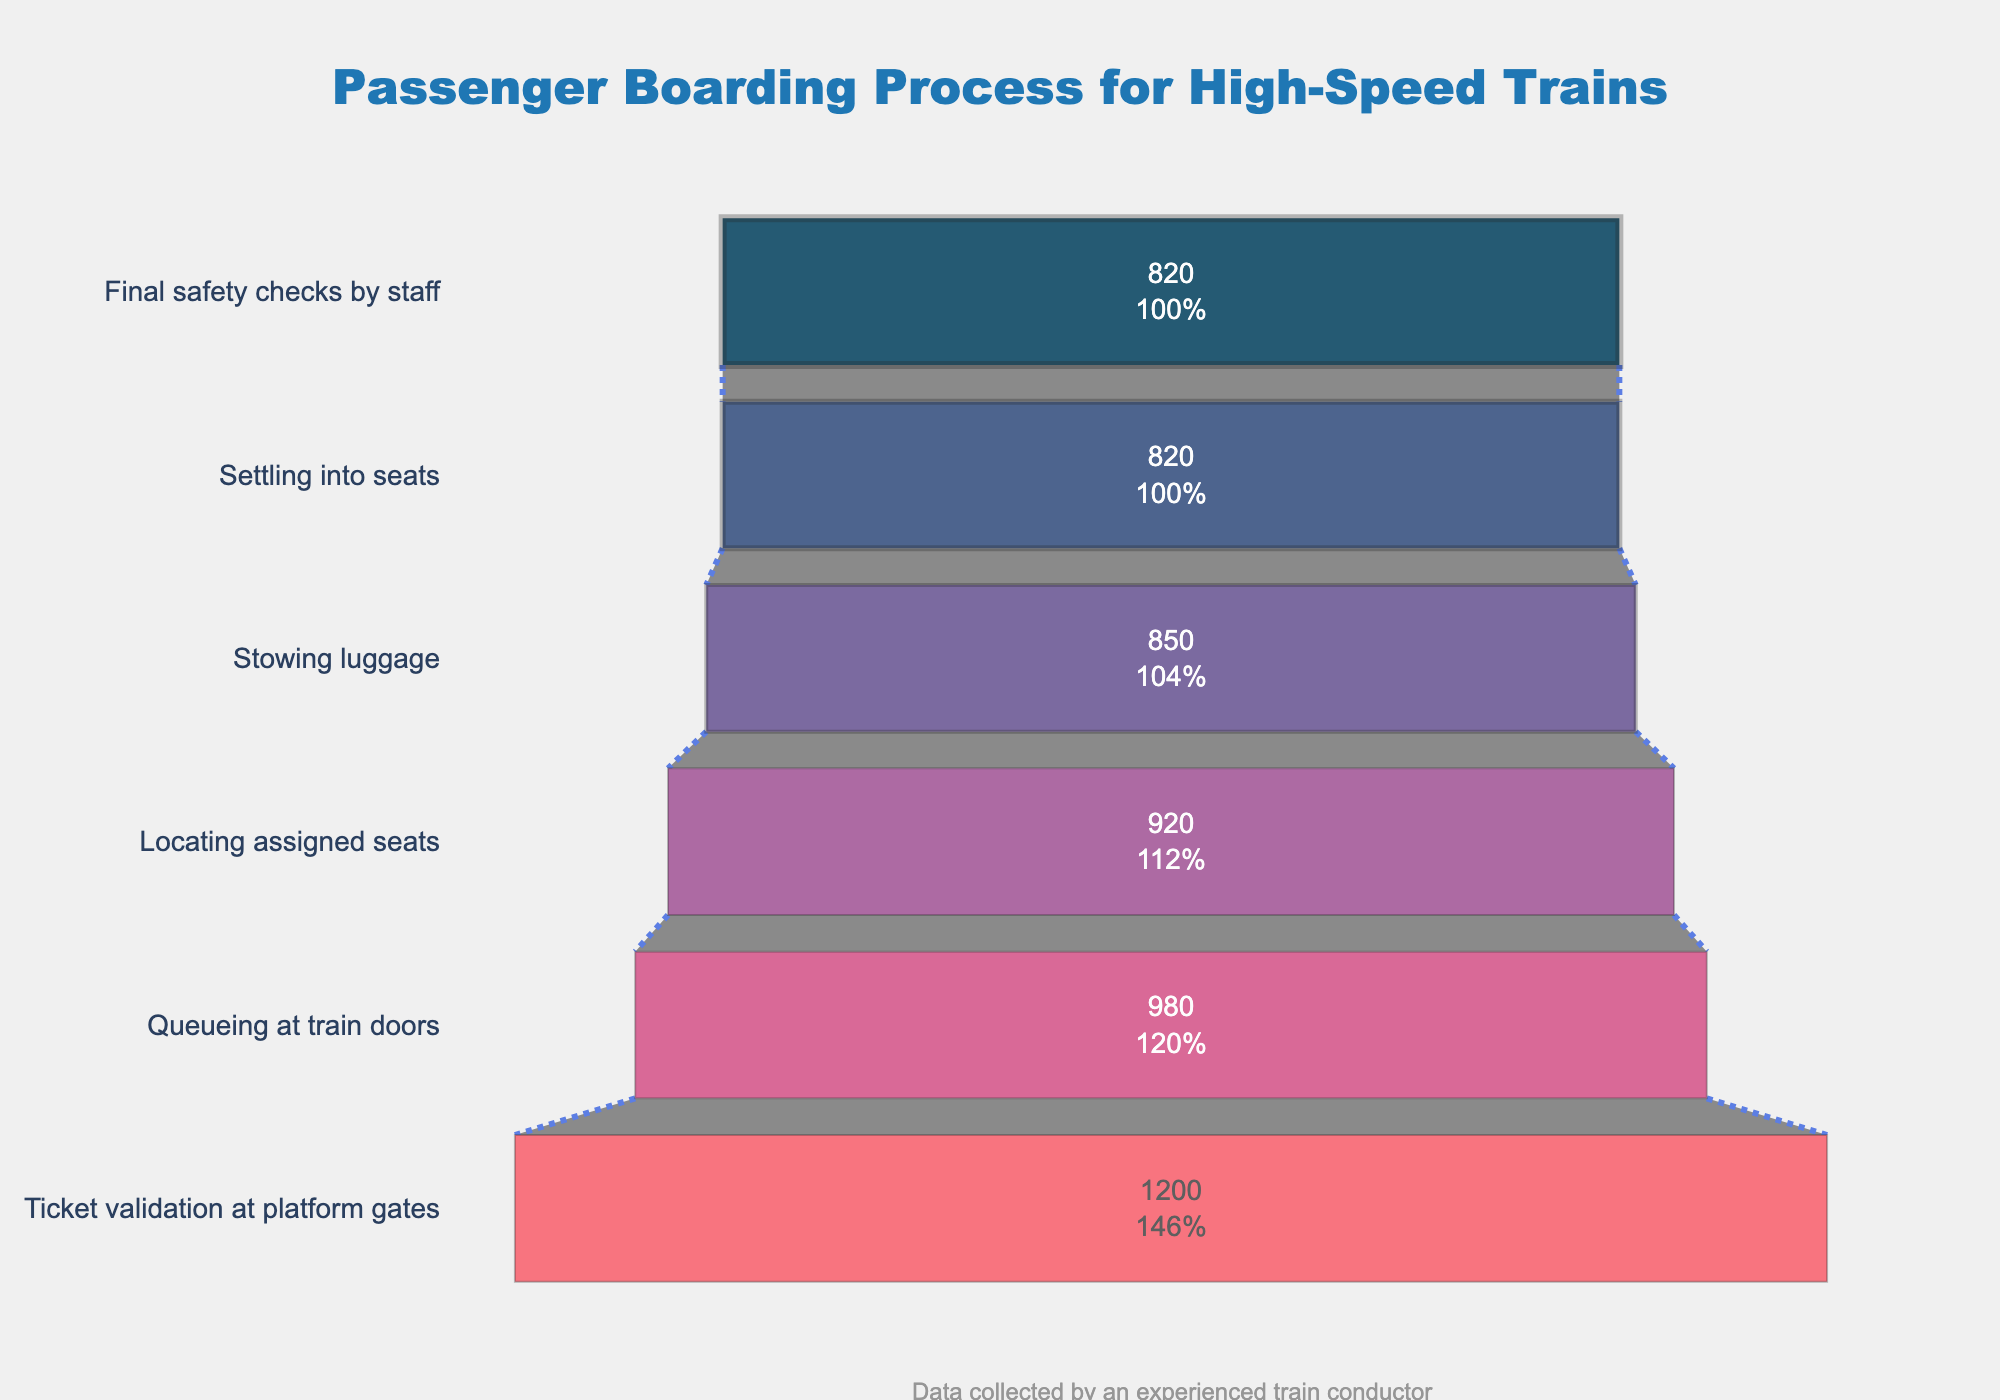What's the title of the funnel chart? The title of the funnel chart is usually displayed at the top of the figure.
Answer: Passenger Boarding Process for High-Speed Trains What stage has the highest number of passengers? The stage with the highest number of passengers is at the top of the funnel chart.
Answer: Ticket validation at platform gates What stage has the lowest number of passengers? The stage with the lowest number of passengers is at the bottom of the funnel chart.
Answer: Final safety checks by staff What's the percentage drop in passengers from the "Ticket validation at platform gates" stage to the "Queueing at train doors" stage? To calculate the percentage drop, subtract the passengers at the second stage from the first stage, divide by the passengers at the first stage, and multiply by 100. ((1200-980)/1200)*100 = 18.33%
Answer: 18.33% How many more passengers are at the "Queueing at train doors" stage than at the "Stowing luggage" stage? Subtract the number of passengers at "Stowing luggage" from the number of passengers at "Queueing at train doors." 980 - 850 = 130
Answer: 130 What is the sum of passengers from "Locating assigned seats" and "Stowing luggage"? Add the number of passengers at both stages. 920 + 850 = 1770
Answer: 1770 What percentage of the initial passengers remain at the "Final safety checks by staff" stage? The percentage is calculated by dividing the passengers at the final stage by the passengers at the first stage and then multiplying by 100. (820/1200)*100 = 68.33%
Answer: 68.33% Which stage has the highest drop in number of passengers compared to the previous stage? To find this, calculate the drop between each consecutive stage and identify the maximum. The highest drop is from "Ticket validation at platform gates" to "Queueing at train doors" which is 1200 - 980 = 220
Answer: Ticket validation at platform gates to Queueing at train doors Is there any stage where the number of passengers remains unchanged from the previous stage? By observing the chart, look for stages with the same number of passengers as the previous stage.
Answer: Yes, between "Settling into seats" and "Final safety checks by staff" What is the average number of passengers across all stages? Sum the number of passengers across all stages and divide by the number of stages. (1200+980+920+850+820+820)/6 = 931.67
Answer: 931.67 